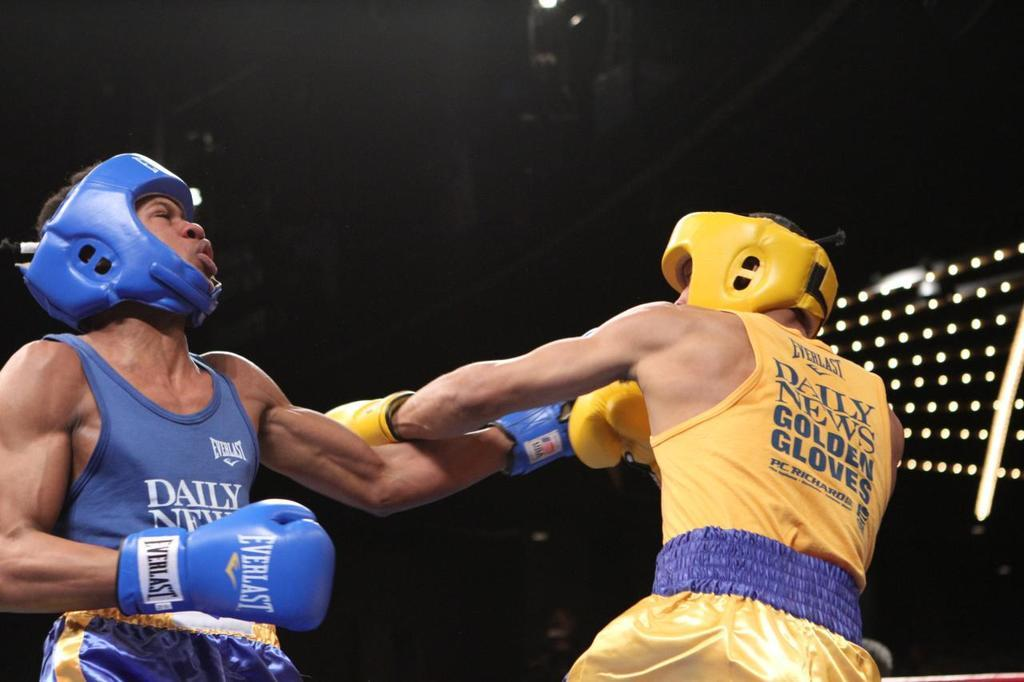How many people are in the image? There are two persons in the image. What are the two persons wearing? Both persons are wearing helmets. What activity are the two persons engaged in? The two persons are playing boxing. What type of locket can be seen around the neck of one of the persons in the image? There is no locket visible around the neck of either person in the image. What day of the week is it in the image? The day of the week is not visible or mentioned in the image. 